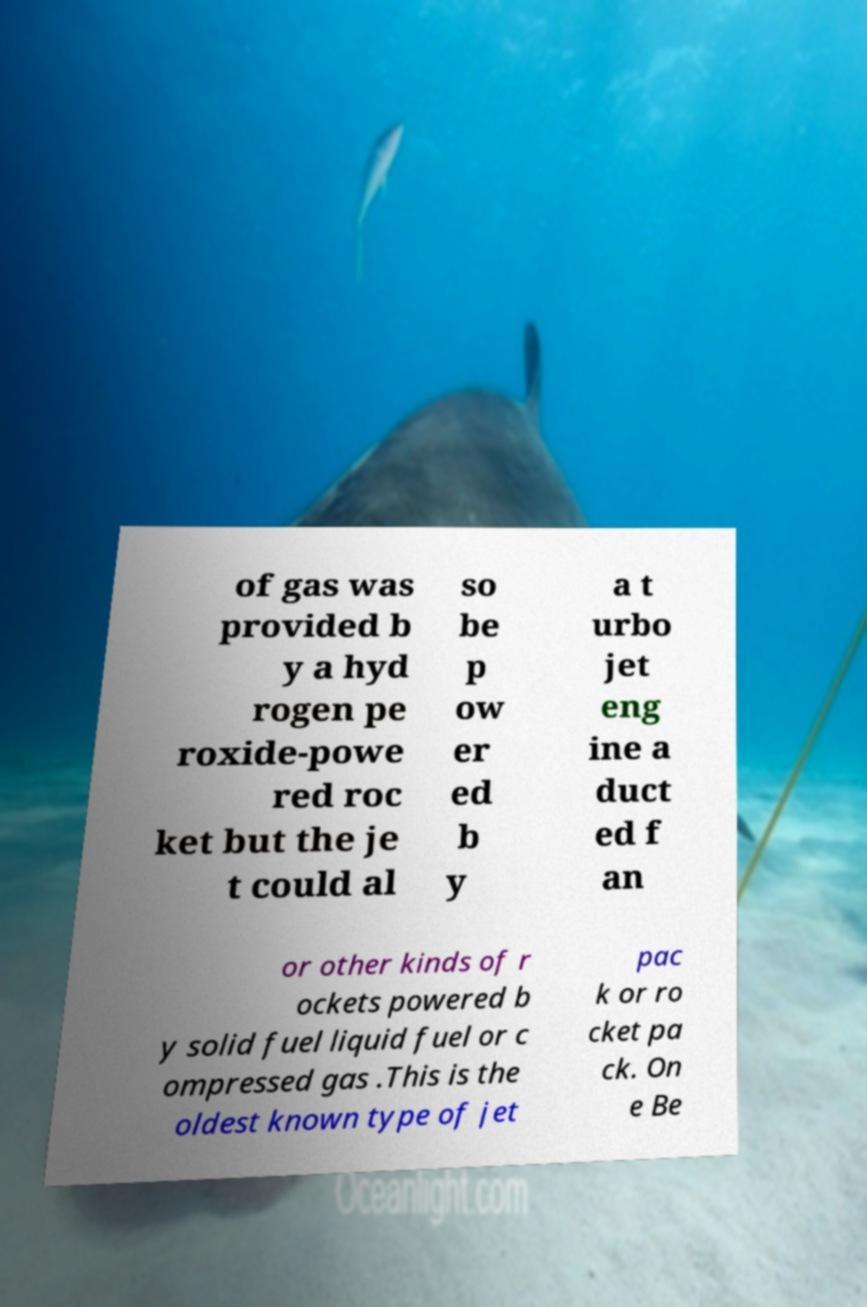For documentation purposes, I need the text within this image transcribed. Could you provide that? of gas was provided b y a hyd rogen pe roxide-powe red roc ket but the je t could al so be p ow er ed b y a t urbo jet eng ine a duct ed f an or other kinds of r ockets powered b y solid fuel liquid fuel or c ompressed gas .This is the oldest known type of jet pac k or ro cket pa ck. On e Be 